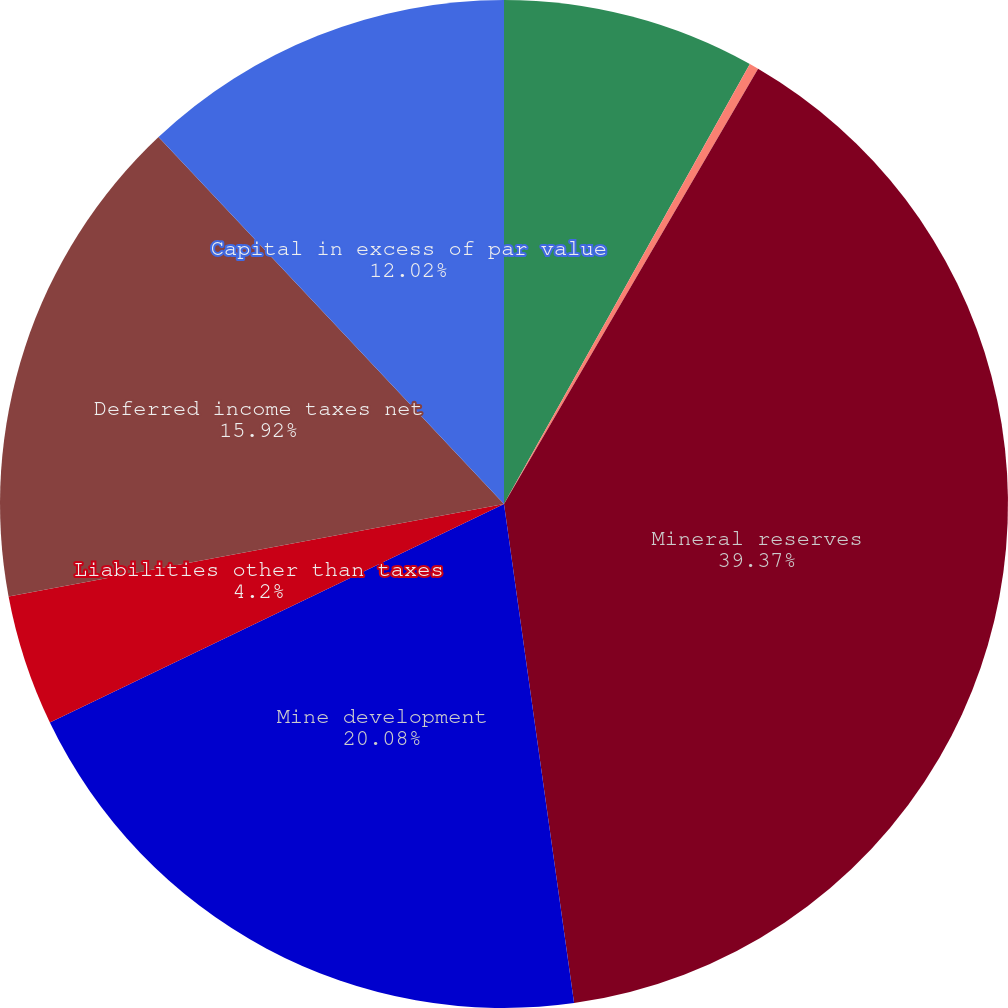Convert chart. <chart><loc_0><loc_0><loc_500><loc_500><pie_chart><fcel>Cash<fcel>Other current assets<fcel>Mineral reserves<fcel>Mine development<fcel>Liabilities other than taxes<fcel>Deferred income taxes net<fcel>Capital in excess of par value<nl><fcel>8.11%<fcel>0.3%<fcel>39.37%<fcel>20.08%<fcel>4.2%<fcel>15.92%<fcel>12.02%<nl></chart> 